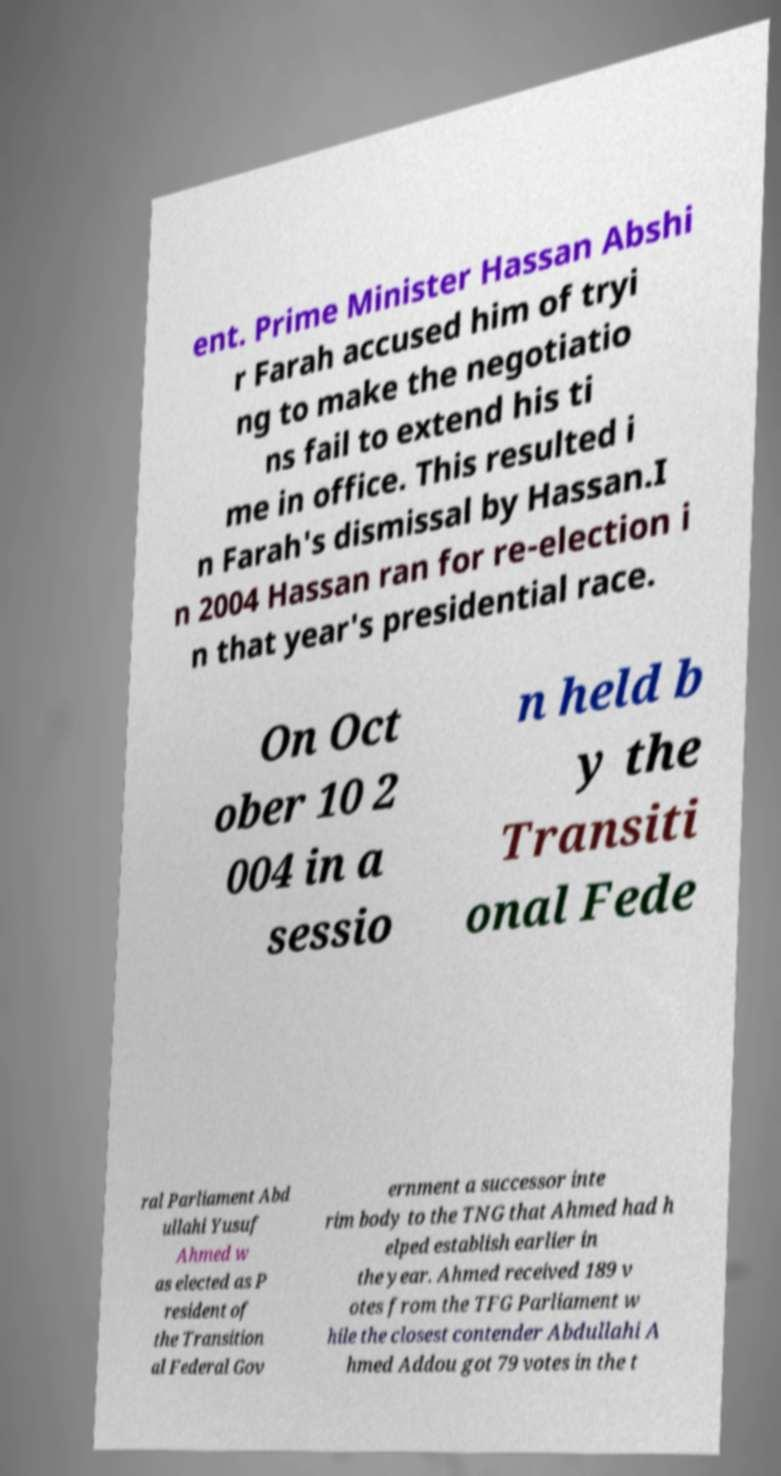What messages or text are displayed in this image? I need them in a readable, typed format. ent. Prime Minister Hassan Abshi r Farah accused him of tryi ng to make the negotiatio ns fail to extend his ti me in office. This resulted i n Farah's dismissal by Hassan.I n 2004 Hassan ran for re-election i n that year's presidential race. On Oct ober 10 2 004 in a sessio n held b y the Transiti onal Fede ral Parliament Abd ullahi Yusuf Ahmed w as elected as P resident of the Transition al Federal Gov ernment a successor inte rim body to the TNG that Ahmed had h elped establish earlier in the year. Ahmed received 189 v otes from the TFG Parliament w hile the closest contender Abdullahi A hmed Addou got 79 votes in the t 